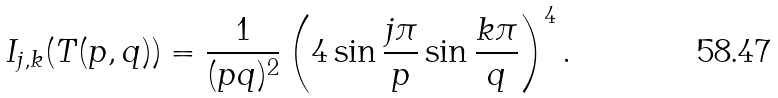<formula> <loc_0><loc_0><loc_500><loc_500>I _ { j , k } ( T ( p , q ) ) = \frac { 1 } { ( p q ) ^ { 2 } } \left ( 4 \sin \frac { j \pi } { p } \sin \frac { k \pi } { q } \right ) ^ { 4 } .</formula> 